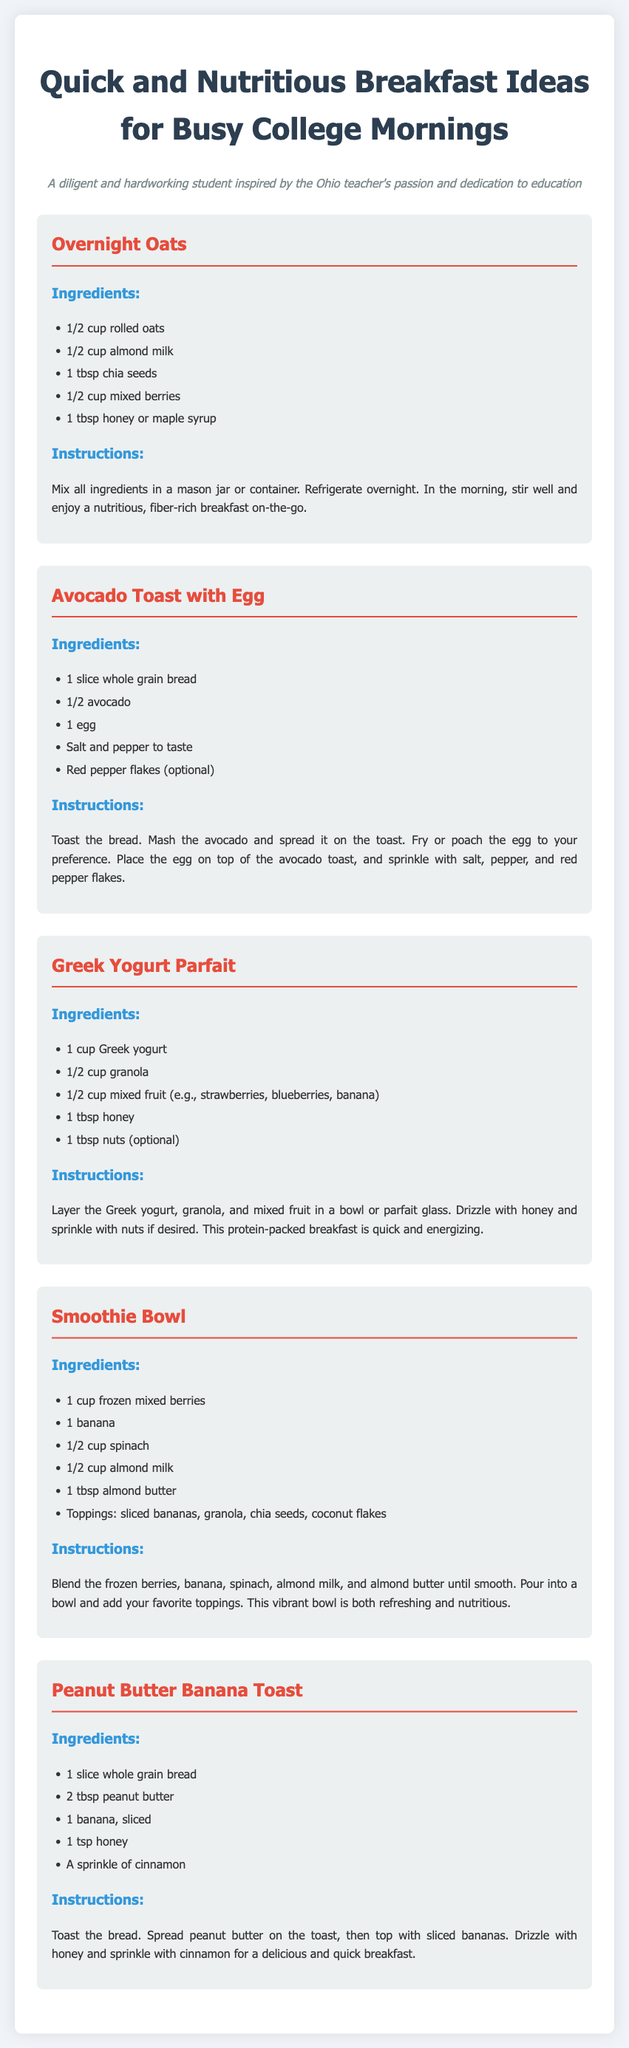What is the first recipe listed? The first recipe in the document is "Overnight Oats."
Answer: Overnight Oats How many ingredients are in the Avocado Toast with Egg recipe? The Avocado Toast with Egg recipe contains 5 ingredients.
Answer: 5 ingredients What is a key ingredient in the Greek Yogurt Parfait? A key ingredient in the Greek Yogurt Parfait is Greek yogurt.
Answer: Greek yogurt What toppings are suggested for the Smoothie Bowl? The suggested toppings for the Smoothie Bowl include sliced bananas, granola, chia seeds, and coconut flakes.
Answer: sliced bananas, granola, chia seeds, coconut flakes What type of bread is used in the Peanut Butter Banana Toast? The type of bread used in the Peanut Butter Banana Toast is whole grain bread.
Answer: whole grain bread What is the main nutritional benefit of the Overnight Oats? The main nutritional benefit of the Overnight Oats is that it is fiber-rich.
Answer: fiber-rich How do you prepare the Greek Yogurt Parfait? The Greek Yogurt Parfait is prepared by layering Greek yogurt, granola, and mixed fruit.
Answer: layering Greek yogurt, granola, and mixed fruit What is the cooking method for the egg in the Avocado Toast with Egg? The egg in the Avocado Toast can be fried or poached.
Answer: fried or poached What is the purpose of refrigerating the Overnight Oats? Refrigerating the Overnight Oats allows the ingredients to meld and soften overnight.
Answer: to meld and soften overnight 